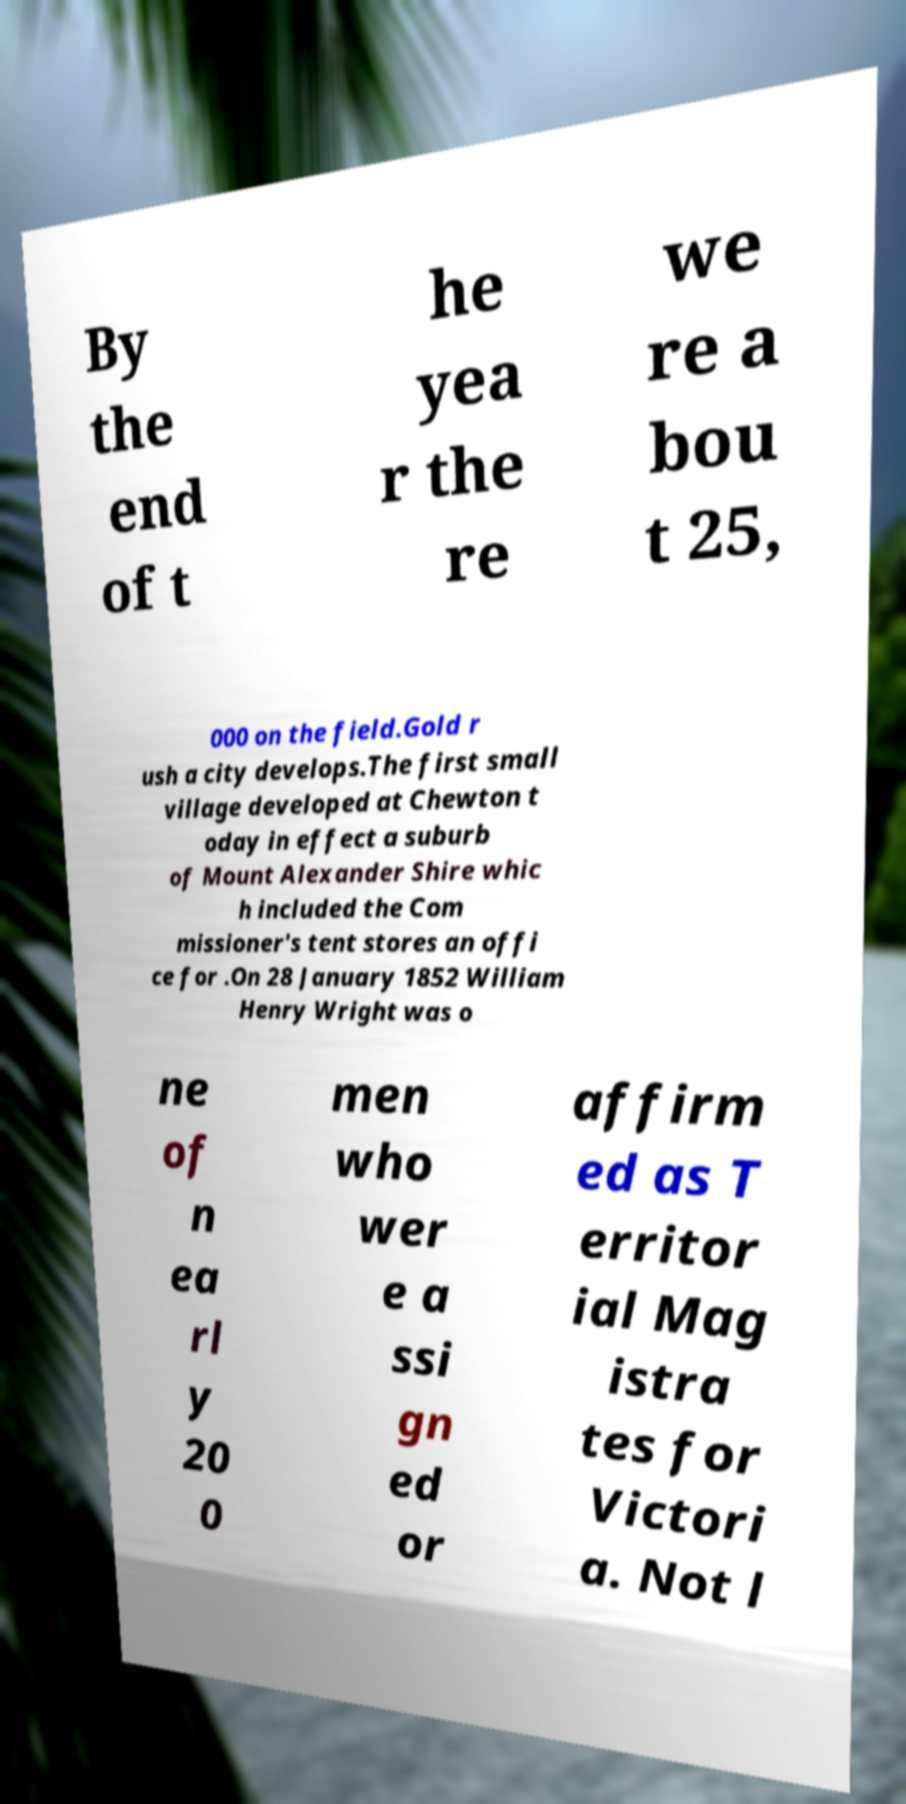Could you extract and type out the text from this image? By the end of t he yea r the re we re a bou t 25, 000 on the field.Gold r ush a city develops.The first small village developed at Chewton t oday in effect a suburb of Mount Alexander Shire whic h included the Com missioner's tent stores an offi ce for .On 28 January 1852 William Henry Wright was o ne of n ea rl y 20 0 men who wer e a ssi gn ed or affirm ed as T erritor ial Mag istra tes for Victori a. Not l 